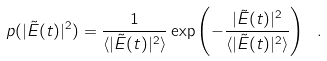<formula> <loc_0><loc_0><loc_500><loc_500>p ( | \tilde { E } ( t ) | ^ { 2 } ) = \frac { 1 } { \langle | \tilde { E } ( t ) | ^ { 2 } \rangle } \exp \left ( - \frac { | \tilde { E } ( t ) | ^ { 2 } } { \langle | \tilde { E } ( t ) | ^ { 2 } \rangle } \right ) \ .</formula> 